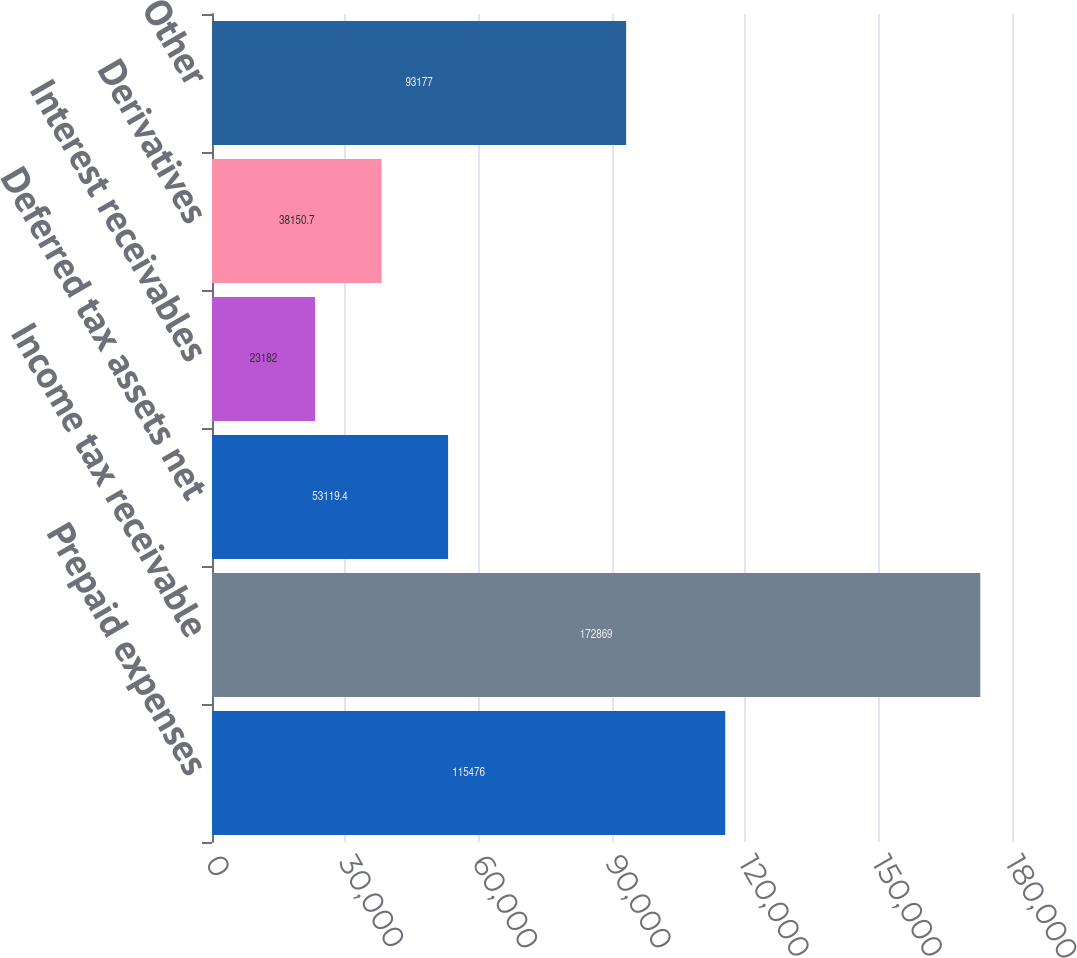Convert chart. <chart><loc_0><loc_0><loc_500><loc_500><bar_chart><fcel>Prepaid expenses<fcel>Income tax receivable<fcel>Deferred tax assets net<fcel>Interest receivables<fcel>Derivatives<fcel>Other<nl><fcel>115476<fcel>172869<fcel>53119.4<fcel>23182<fcel>38150.7<fcel>93177<nl></chart> 